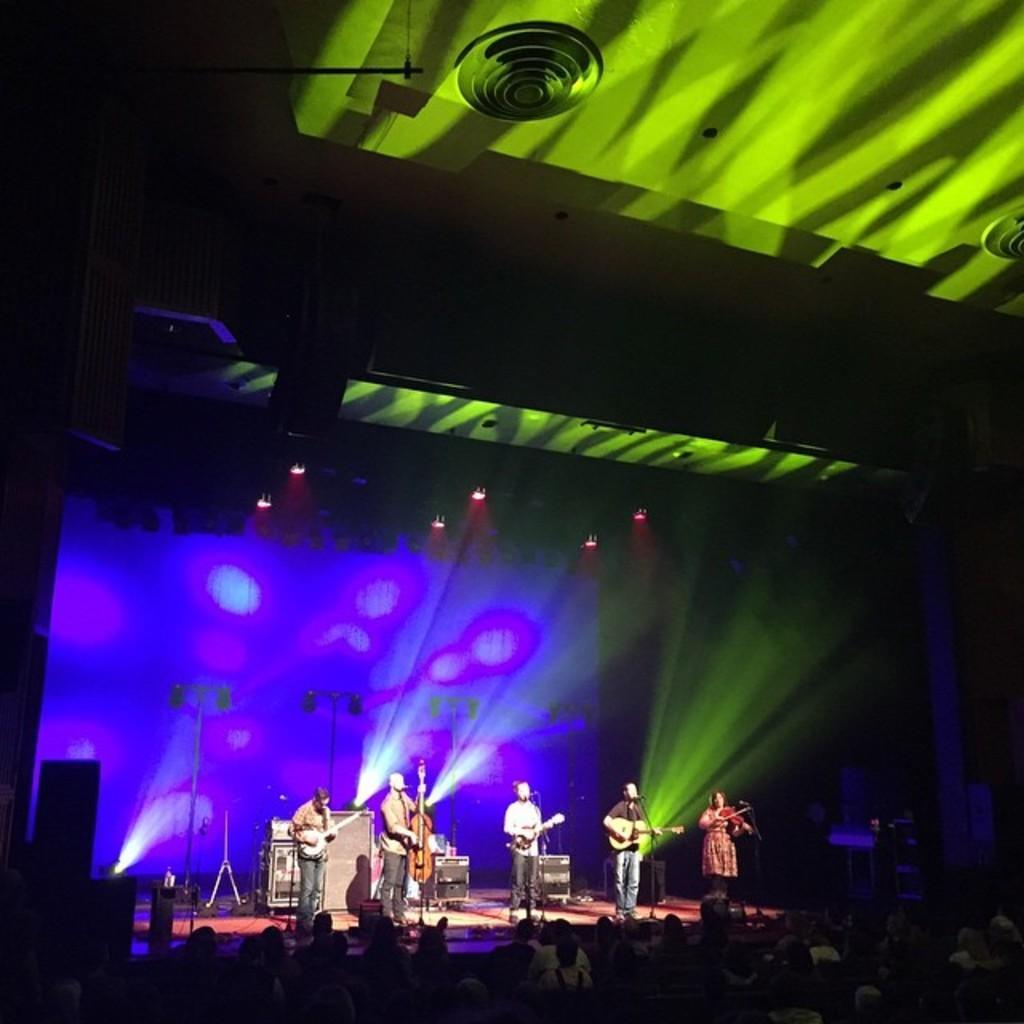How would you summarize this image in a sentence or two? This picture describes about group of people, few people are playing musical instruments in front of the microphones, and we can find few lights. 